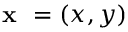Convert formula to latex. <formula><loc_0><loc_0><loc_500><loc_500>x = ( x , y )</formula> 